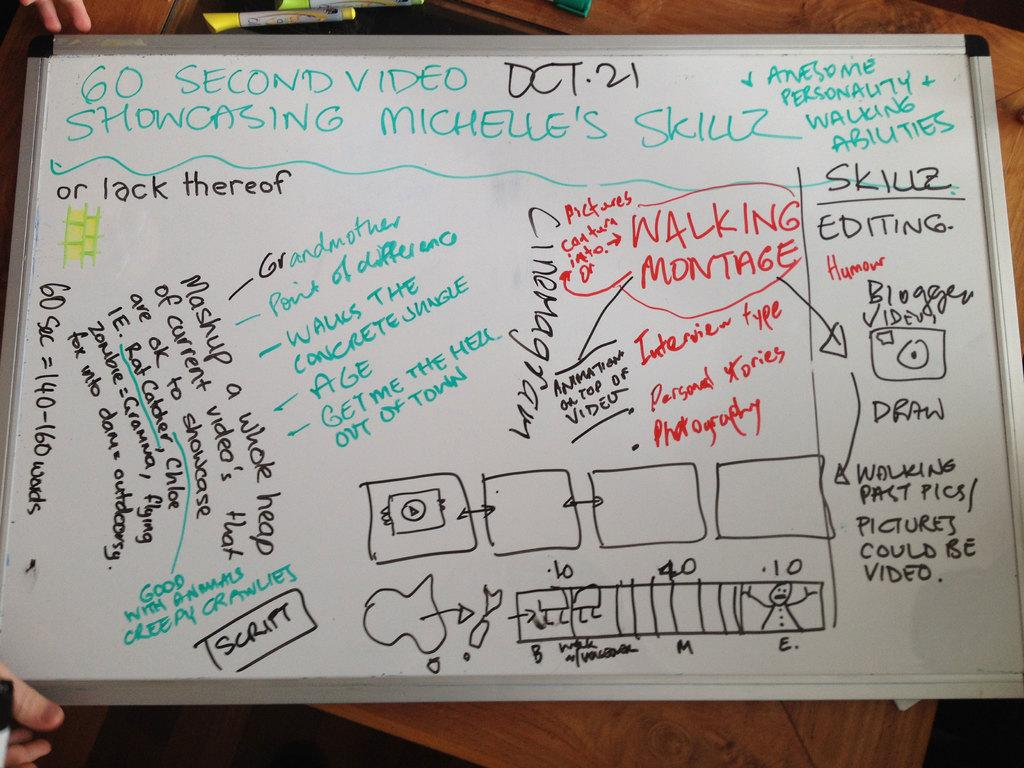<image>
Render a clear and concise summary of the photo. a white board showcasing the Michelle Skillz and video 